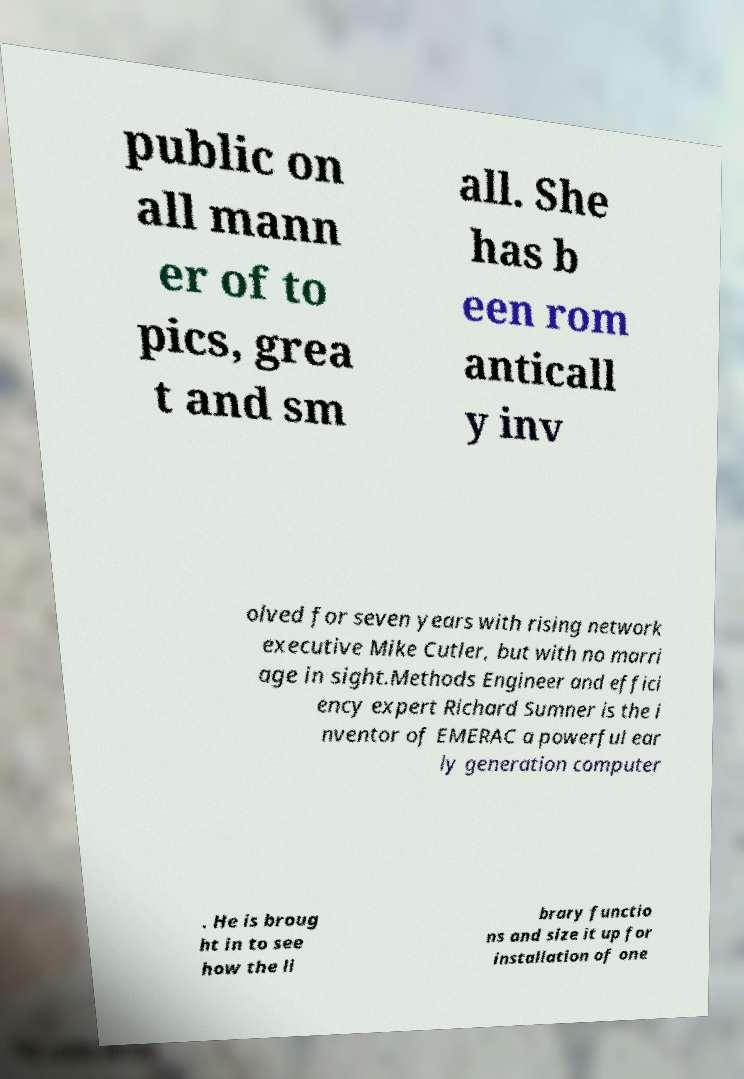Can you accurately transcribe the text from the provided image for me? public on all mann er of to pics, grea t and sm all. She has b een rom anticall y inv olved for seven years with rising network executive Mike Cutler, but with no marri age in sight.Methods Engineer and effici ency expert Richard Sumner is the i nventor of EMERAC a powerful ear ly generation computer . He is broug ht in to see how the li brary functio ns and size it up for installation of one 